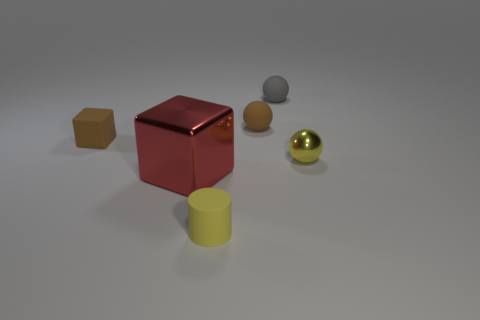Subtract all matte balls. How many balls are left? 1 Add 4 tiny brown balls. How many objects exist? 10 Subtract all cubes. How many objects are left? 4 Add 6 tiny yellow metal things. How many tiny yellow metal things are left? 7 Add 3 small brown matte spheres. How many small brown matte spheres exist? 4 Subtract 0 green cubes. How many objects are left? 6 Subtract all yellow matte cubes. Subtract all tiny spheres. How many objects are left? 3 